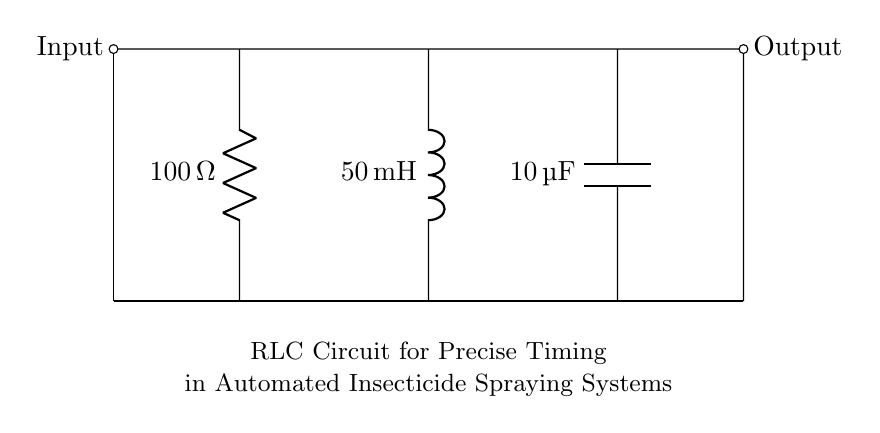What is the resistance value in this circuit? The resistance value is indicated near the resistor symbol and is labeled as one hundred ohms.
Answer: one hundred ohms What is the inductance value in this circuit? The inductance value is specified next to the inductor symbol and is stated as fifty milli-henries.
Answer: fifty milli-henries What is the capacitance value in this circuit? The capacitance value is given next to the capacitor symbol and is identified as ten micro-farads.
Answer: ten micro-farads What is the output connection of this circuit? The output connection is shown at the right side of the circuit diagram, which is the terminal where the output signal can be taken.
Answer: Output What is the purpose of using an RLC circuit in automated insecticide spraying systems? The RLC circuit can create precise timing mechanisms due to its ability to resonate and filter signals, which is essential for controlling the timing of the spraying process.
Answer: timing control How does the RLC circuit influence the timing in spraying systems? The RLC circuit's combination of resistance, inductance, and capacitance allows it to create a specific time delay or oscillation frequency that can be tuned for accurate timing in the spraying process.
Answer: precise timing What components are responsible for energy storage in this circuit? The inductor and capacitor are the components that store energy; the inductor stores energy in a magnetic field, while the capacitor stores energy in an electric field.
Answer: inductor and capacitor 